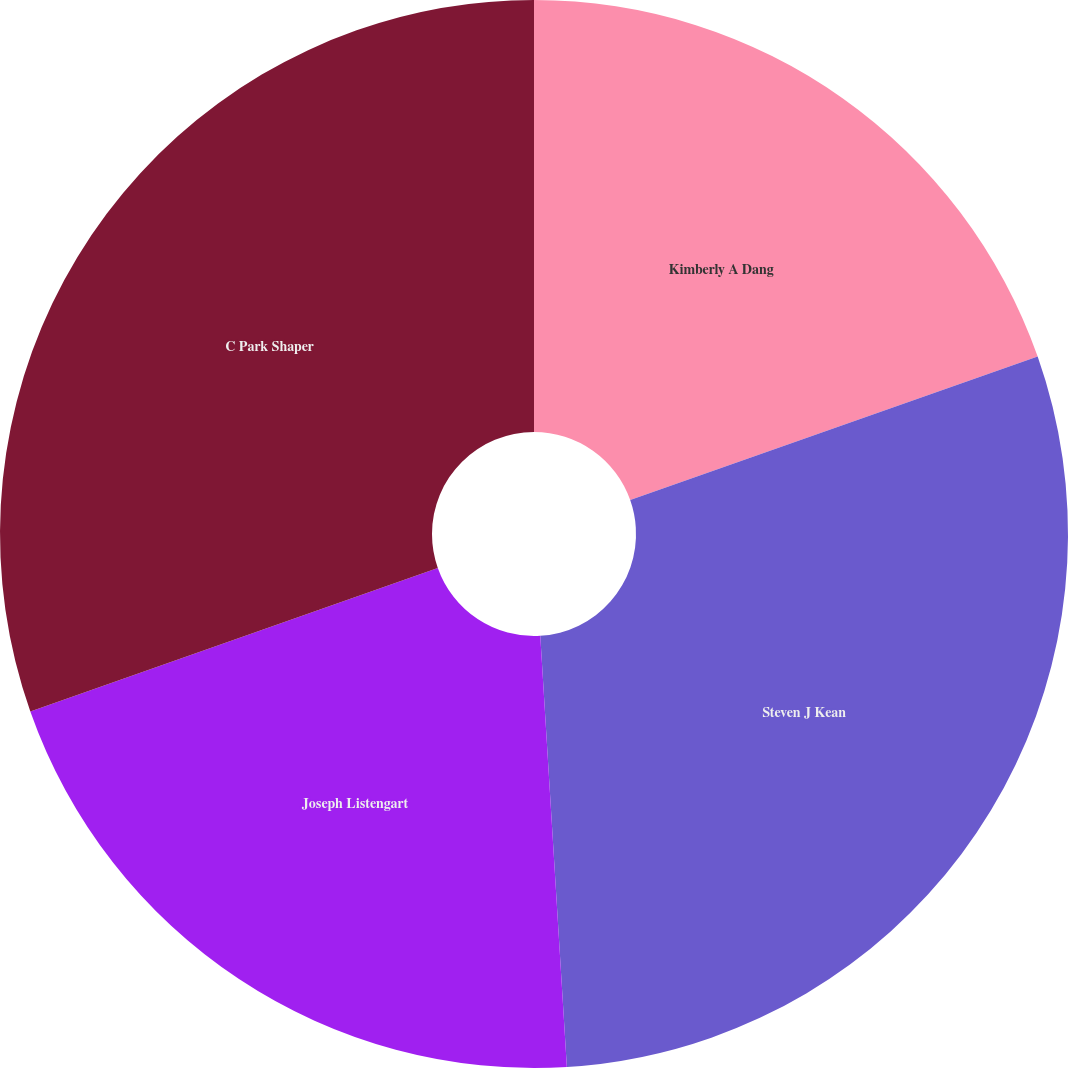Convert chart to OTSL. <chart><loc_0><loc_0><loc_500><loc_500><pie_chart><fcel>Kimberly A Dang<fcel>Steven J Kean<fcel>Joseph Listengart<fcel>C Park Shaper<nl><fcel>19.61%<fcel>29.41%<fcel>20.59%<fcel>30.39%<nl></chart> 